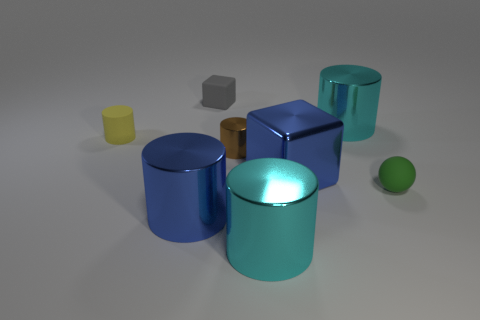Comparing the reflective qualities of the objects, which ones stand out the most, and why? The two shiny cylinders, one bronze and one blue, stand out the most in terms of reflective qualities. Their surfaces appear glossy and reflect the light, making them more visually prominent compared to the matte finishes of the other objects, which absorb more light and therefore have less sheen. 